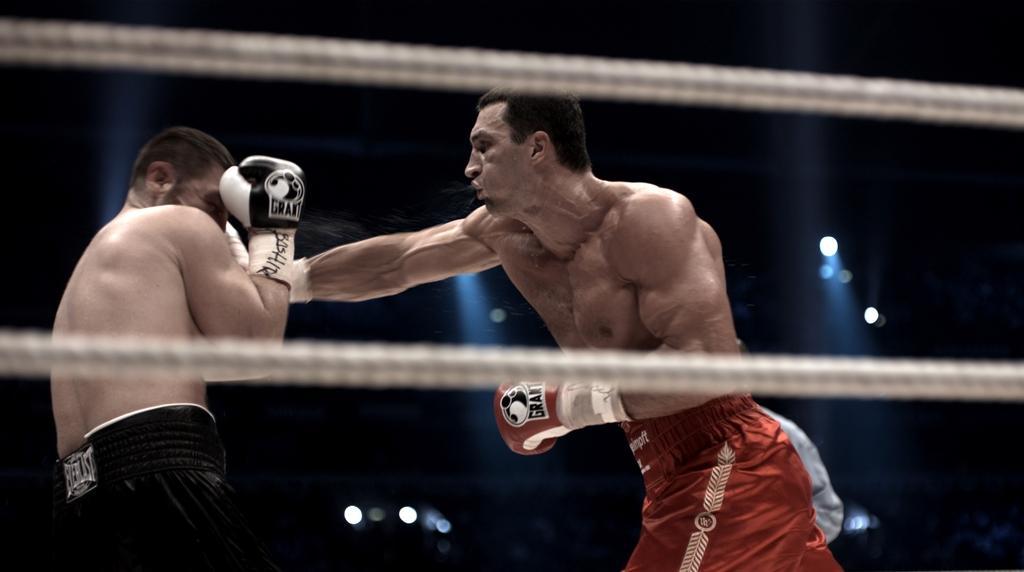How would you summarize this image in a sentence or two? In this picture we can see ropes and few people, two men wore gloves, in the background we can see few lights. 